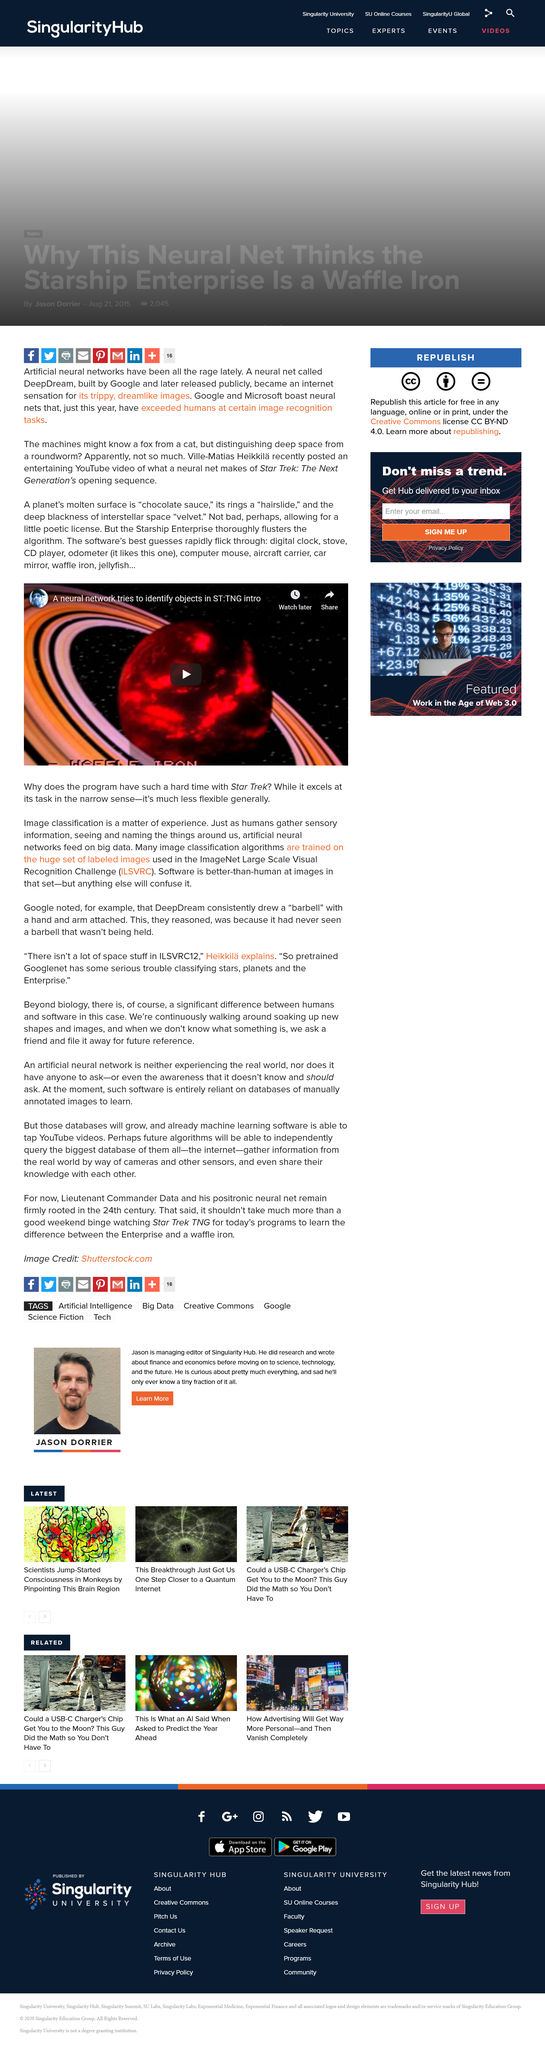Outline some significant characteristics in this image. The television show named in the article is the Starship Enterprise from Star Trek. The software incorrectly identifies the planet's rings as a hairslide. The software has the ability to identify a planet's molten surface as chocolate sauce. 